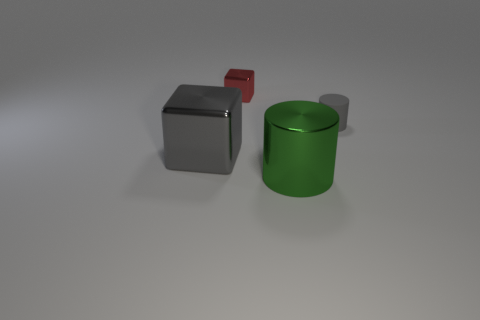Are there any large green objects?
Make the answer very short. Yes. Do the cylinder that is behind the green metallic cylinder and the big gray object have the same material?
Make the answer very short. No. Is there a gray rubber thing of the same shape as the red metal thing?
Keep it short and to the point. No. Is the number of green cylinders that are to the right of the tiny cube the same as the number of metal cubes?
Your response must be concise. No. There is a large thing in front of the cube in front of the red thing; what is it made of?
Your answer should be very brief. Metal. What is the shape of the gray metal object?
Ensure brevity in your answer.  Cube. Are there the same number of matte cylinders that are behind the tiny gray thing and large gray metallic blocks that are on the right side of the green thing?
Your answer should be very brief. Yes. Does the shiny block that is to the left of the small red block have the same color as the tiny thing that is behind the tiny rubber object?
Provide a succinct answer. No. Is the number of big objects behind the green thing greater than the number of yellow metallic things?
Provide a short and direct response. Yes. What shape is the large gray object that is made of the same material as the small red thing?
Keep it short and to the point. Cube. 